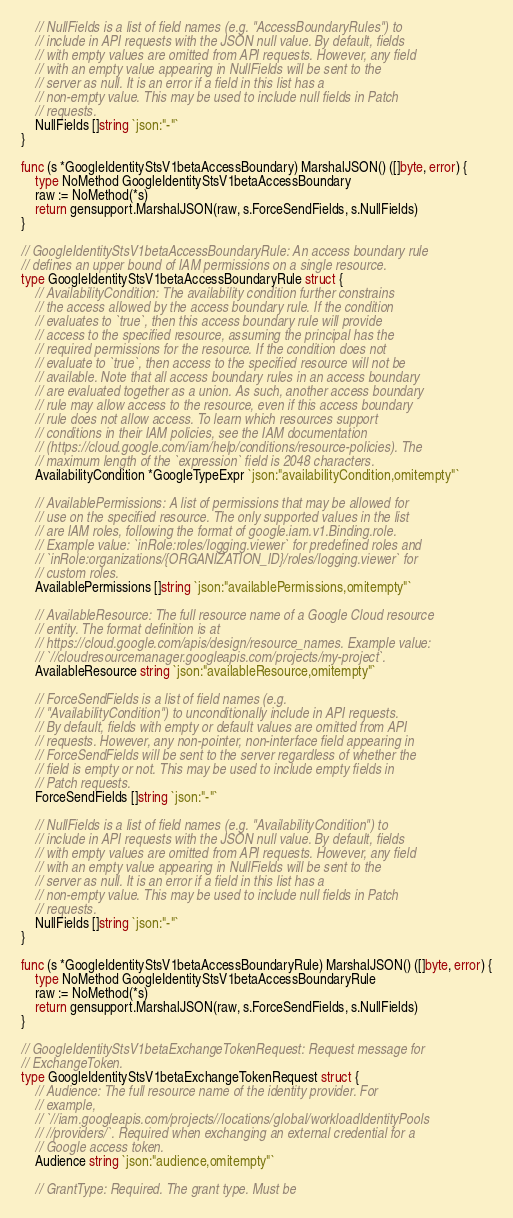<code> <loc_0><loc_0><loc_500><loc_500><_Go_>
	// NullFields is a list of field names (e.g. "AccessBoundaryRules") to
	// include in API requests with the JSON null value. By default, fields
	// with empty values are omitted from API requests. However, any field
	// with an empty value appearing in NullFields will be sent to the
	// server as null. It is an error if a field in this list has a
	// non-empty value. This may be used to include null fields in Patch
	// requests.
	NullFields []string `json:"-"`
}

func (s *GoogleIdentityStsV1betaAccessBoundary) MarshalJSON() ([]byte, error) {
	type NoMethod GoogleIdentityStsV1betaAccessBoundary
	raw := NoMethod(*s)
	return gensupport.MarshalJSON(raw, s.ForceSendFields, s.NullFields)
}

// GoogleIdentityStsV1betaAccessBoundaryRule: An access boundary rule
// defines an upper bound of IAM permissions on a single resource.
type GoogleIdentityStsV1betaAccessBoundaryRule struct {
	// AvailabilityCondition: The availability condition further constrains
	// the access allowed by the access boundary rule. If the condition
	// evaluates to `true`, then this access boundary rule will provide
	// access to the specified resource, assuming the principal has the
	// required permissions for the resource. If the condition does not
	// evaluate to `true`, then access to the specified resource will not be
	// available. Note that all access boundary rules in an access boundary
	// are evaluated together as a union. As such, another access boundary
	// rule may allow access to the resource, even if this access boundary
	// rule does not allow access. To learn which resources support
	// conditions in their IAM policies, see the IAM documentation
	// (https://cloud.google.com/iam/help/conditions/resource-policies). The
	// maximum length of the `expression` field is 2048 characters.
	AvailabilityCondition *GoogleTypeExpr `json:"availabilityCondition,omitempty"`

	// AvailablePermissions: A list of permissions that may be allowed for
	// use on the specified resource. The only supported values in the list
	// are IAM roles, following the format of google.iam.v1.Binding.role.
	// Example value: `inRole:roles/logging.viewer` for predefined roles and
	// `inRole:organizations/{ORGANIZATION_ID}/roles/logging.viewer` for
	// custom roles.
	AvailablePermissions []string `json:"availablePermissions,omitempty"`

	// AvailableResource: The full resource name of a Google Cloud resource
	// entity. The format definition is at
	// https://cloud.google.com/apis/design/resource_names. Example value:
	// `//cloudresourcemanager.googleapis.com/projects/my-project`.
	AvailableResource string `json:"availableResource,omitempty"`

	// ForceSendFields is a list of field names (e.g.
	// "AvailabilityCondition") to unconditionally include in API requests.
	// By default, fields with empty or default values are omitted from API
	// requests. However, any non-pointer, non-interface field appearing in
	// ForceSendFields will be sent to the server regardless of whether the
	// field is empty or not. This may be used to include empty fields in
	// Patch requests.
	ForceSendFields []string `json:"-"`

	// NullFields is a list of field names (e.g. "AvailabilityCondition") to
	// include in API requests with the JSON null value. By default, fields
	// with empty values are omitted from API requests. However, any field
	// with an empty value appearing in NullFields will be sent to the
	// server as null. It is an error if a field in this list has a
	// non-empty value. This may be used to include null fields in Patch
	// requests.
	NullFields []string `json:"-"`
}

func (s *GoogleIdentityStsV1betaAccessBoundaryRule) MarshalJSON() ([]byte, error) {
	type NoMethod GoogleIdentityStsV1betaAccessBoundaryRule
	raw := NoMethod(*s)
	return gensupport.MarshalJSON(raw, s.ForceSendFields, s.NullFields)
}

// GoogleIdentityStsV1betaExchangeTokenRequest: Request message for
// ExchangeToken.
type GoogleIdentityStsV1betaExchangeTokenRequest struct {
	// Audience: The full resource name of the identity provider. For
	// example,
	// `//iam.googleapis.com/projects//locations/global/workloadIdentityPools
	// //providers/`. Required when exchanging an external credential for a
	// Google access token.
	Audience string `json:"audience,omitempty"`

	// GrantType: Required. The grant type. Must be</code> 